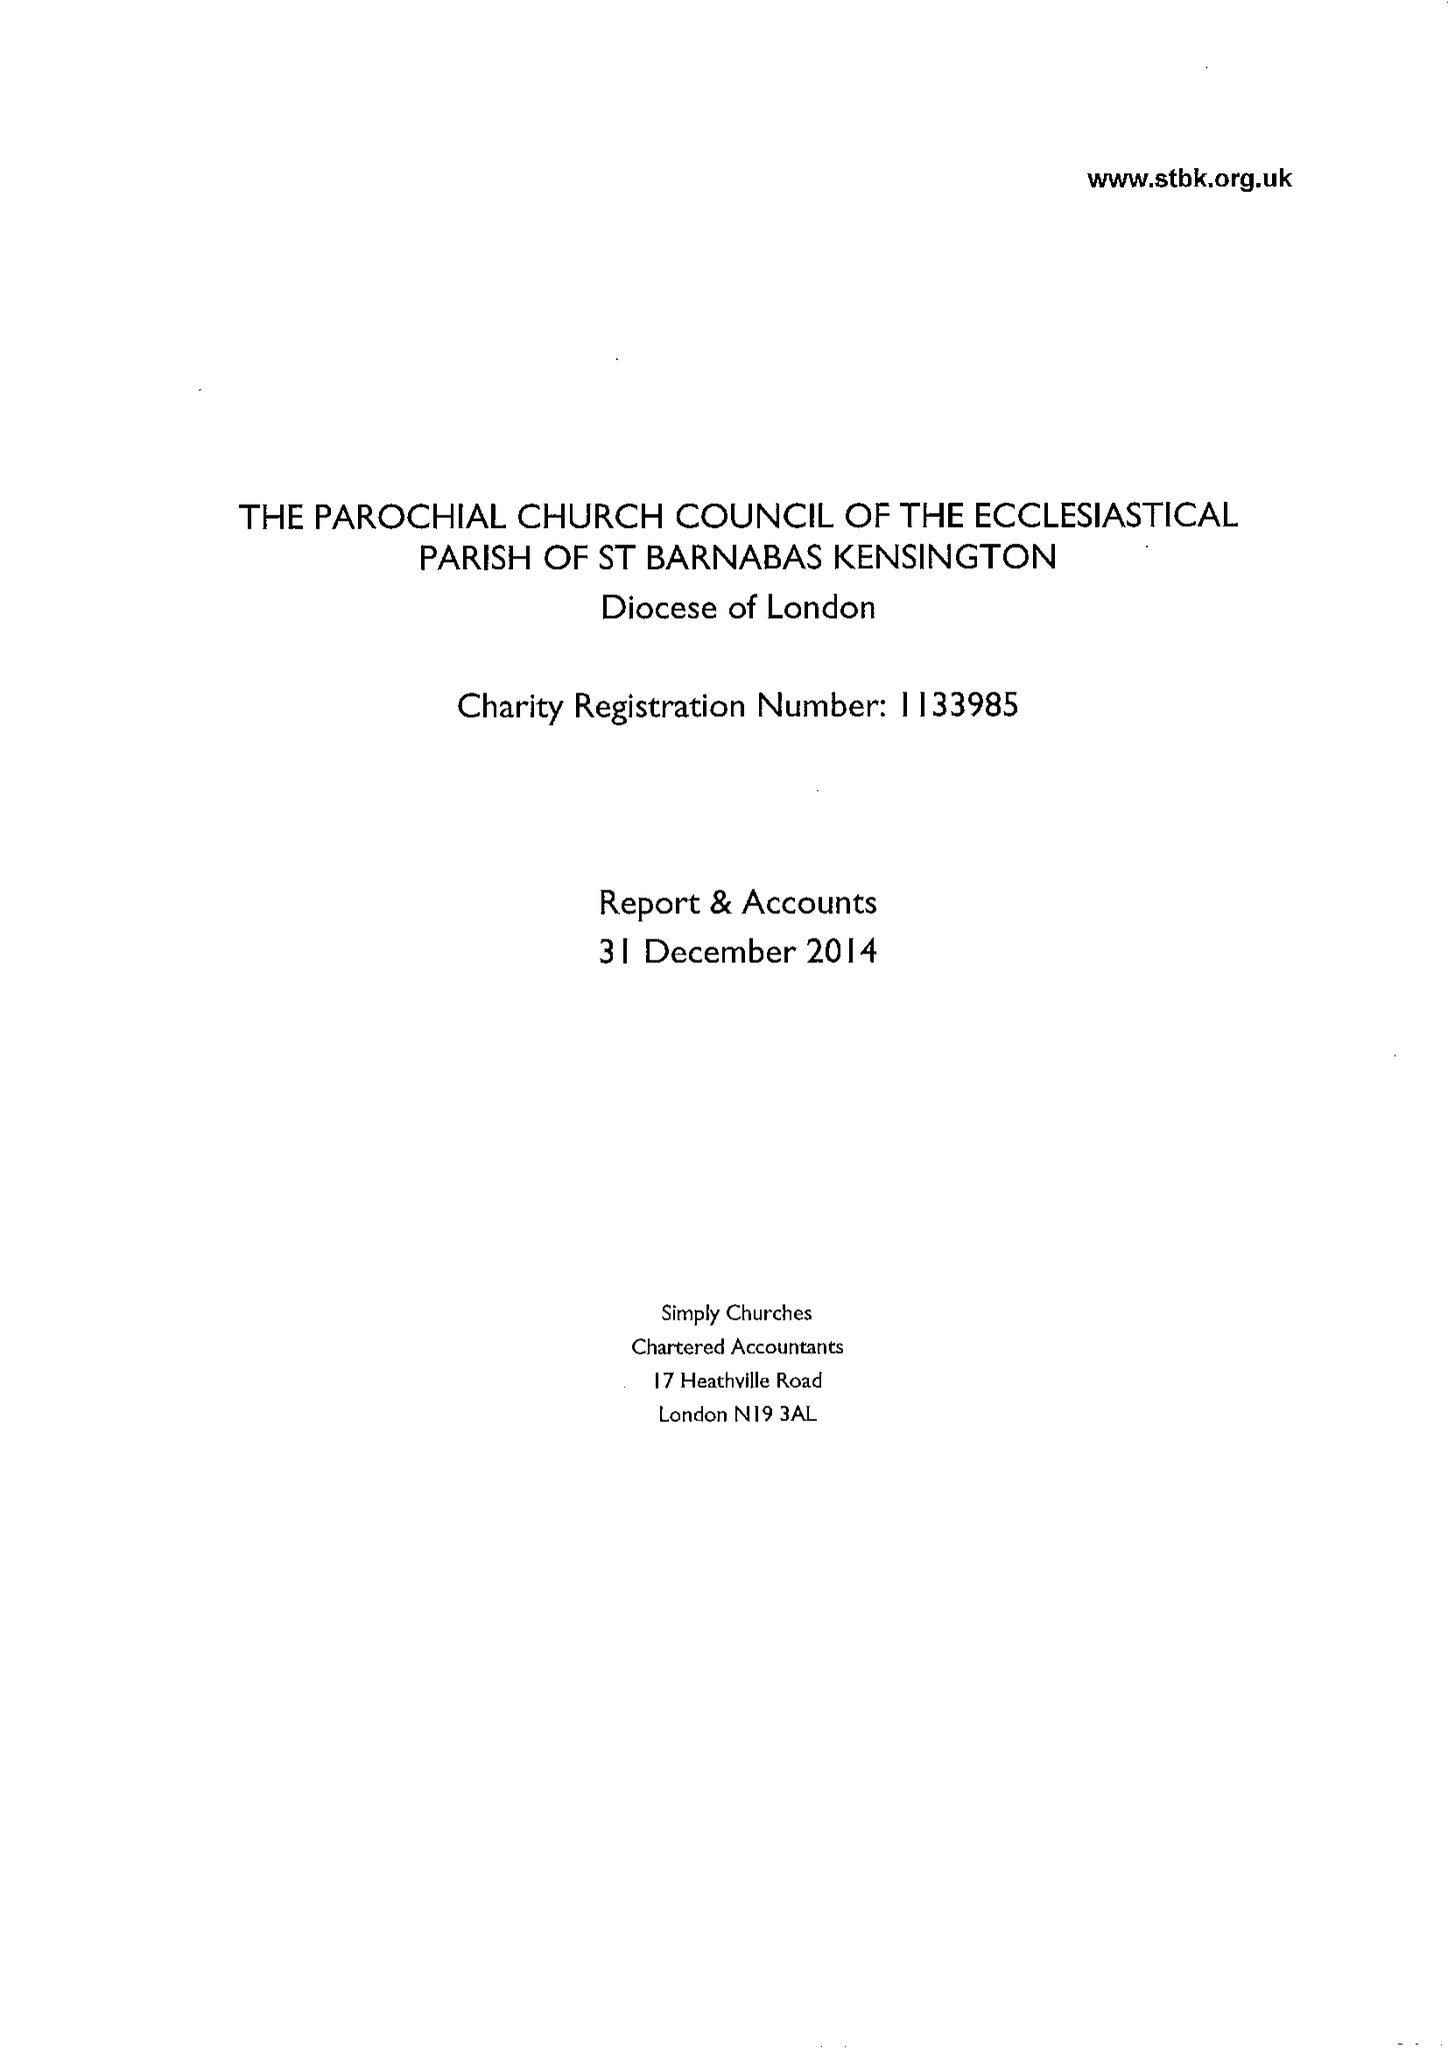What is the value for the charity_number?
Answer the question using a single word or phrase. 1133985 